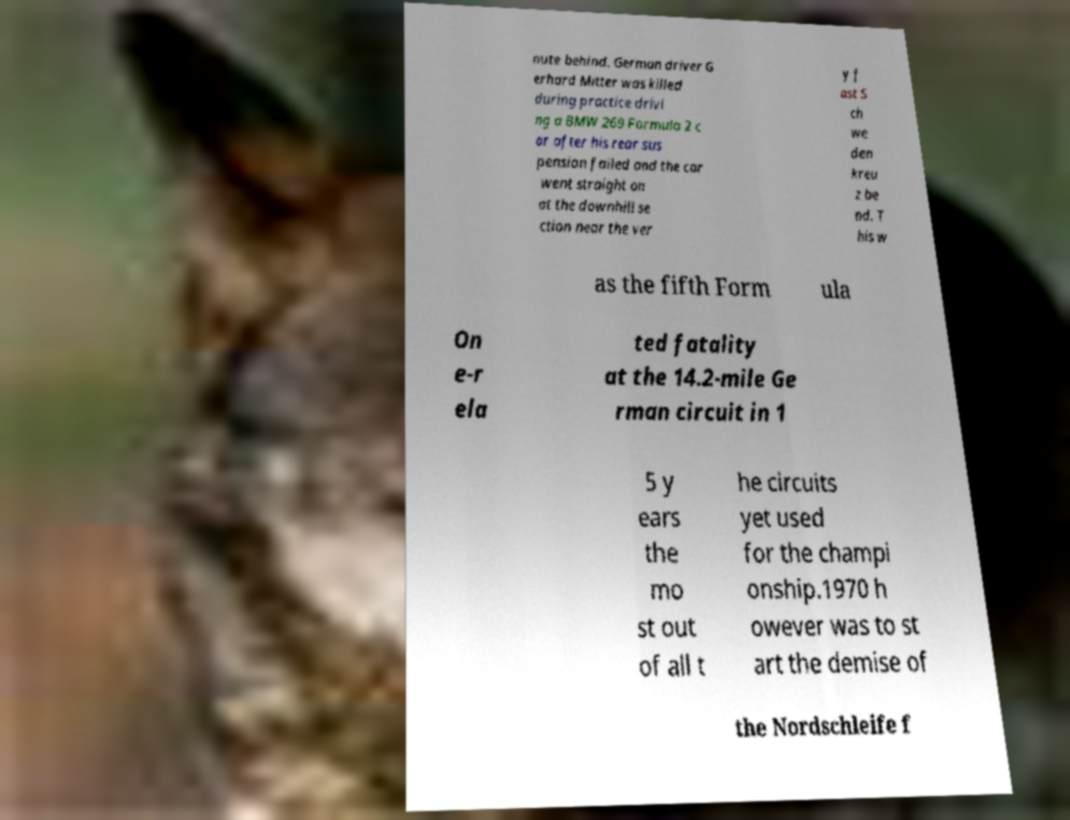For documentation purposes, I need the text within this image transcribed. Could you provide that? nute behind. German driver G erhard Mitter was killed during practice drivi ng a BMW 269 Formula 2 c ar after his rear sus pension failed and the car went straight on at the downhill se ction near the ver y f ast S ch we den kreu z be nd. T his w as the fifth Form ula On e-r ela ted fatality at the 14.2-mile Ge rman circuit in 1 5 y ears the mo st out of all t he circuits yet used for the champi onship.1970 h owever was to st art the demise of the Nordschleife f 